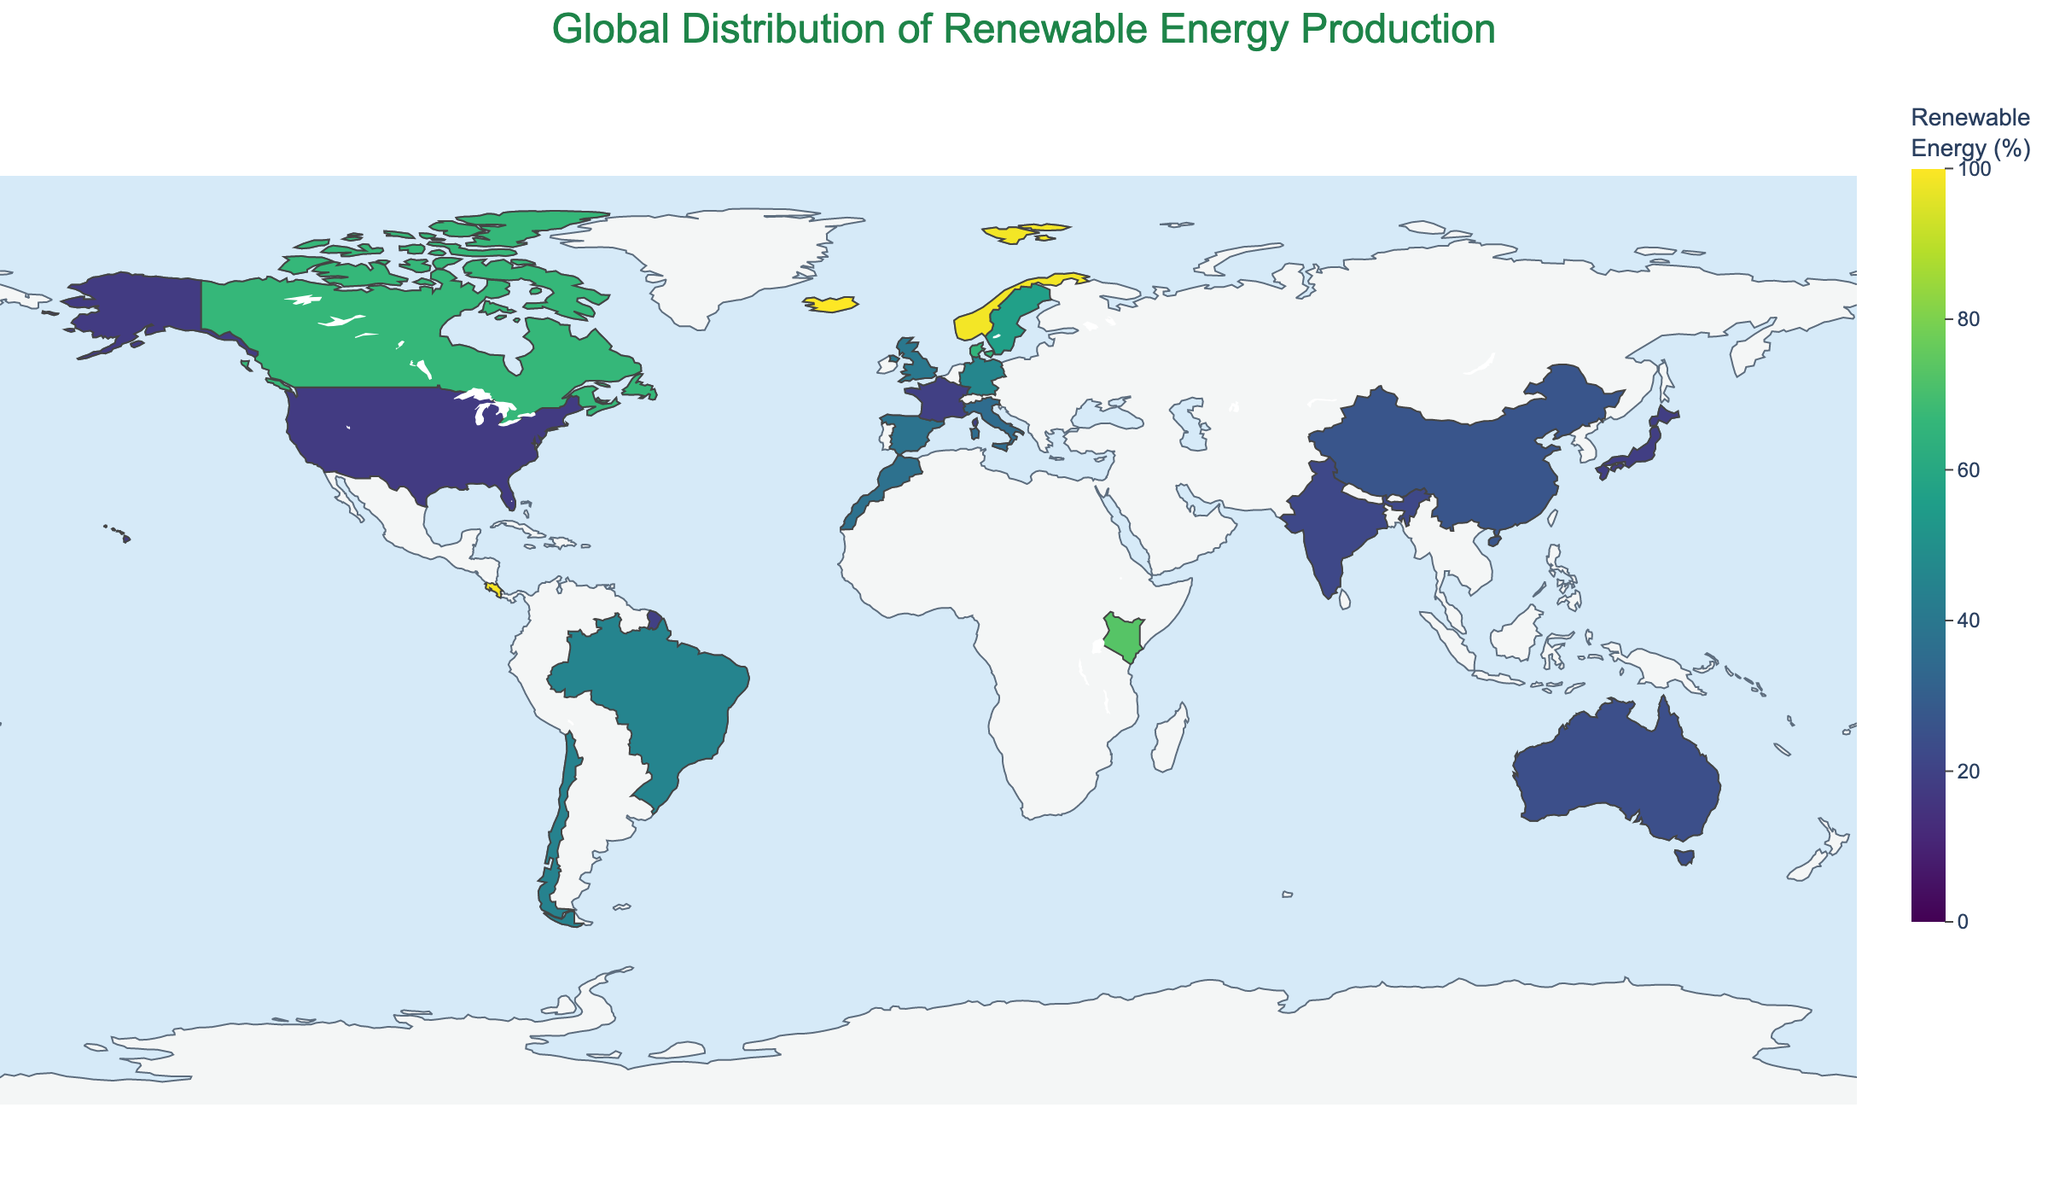Which country produced the highest percentage of renewable energy? Looking at the plot, the color scale represents renewable energy percentages ranging from 0 to 100%. Iceland is at the highest end of this scale, with a percentage of 100%.
Answer: Iceland What is the renewable energy percentage for Kenya? Referring to the values in the figure, Kenya shows a renewable energy percentage, which can be identified by its color and corresponding hover information. Kenya's renewable energy percentage is 73.1%.
Answer: 73.1% Which continent has the highest average renewable energy production percentage based on the countries shown? By visually inspecting the plot and considering countries from each continent, we calculate the average renewable energy percentages:
- Europe: Germany (46.1), Spain (37.9), UK (40.2), Italy (35.1), Sweden (56.4), Denmark (65.3), Norway (98.4) => Average: (46.1 + 37.9 + 40.2 + 35.1 + 56.4 + 65.3 + 98.4) / 7 ≈ 54.2
- North America: USA (17.5), Canada (66.5) => Average: (17.5 + 66.5) / 2 ≈ 42.0
- South America: Brazil (45.3), Chile (44.5), Costa Rica (99.2) => Average: (45.3 + 44.5 + 99.2) / 3 ≈ 63.0
- Asia: China (26.4), India (21.8), Japan (18.5) => Average: (26.4 + 21.8 + 18.5) / 3 ≈ 22.2
- Africa: Morocco (37.2), Kenya (73.1) => Average: (37.2 + 73.1) / 2 ≈ 55.15
Therefore, South America has the highest average renewable energy production percentage.
Answer: South America Between Germany and Denmark, which country has a greater renewable energy percentage? Comparing the two percentages, Germany has 46.1% whereas Denmark has 65.3%. Since 65.3% is greater than 46.1%, Denmark has a higher renewable energy percentage.
Answer: Denmark Is the renewable energy production percentage in Morocco higher than in Japan and India combined? Morocco's renewable energy percentage is 37.2%. Japan's is 18.5%, and India's is 21.8%. Summing Japan and India's percentages: 18.5 + 21.8 = 40.3. Comparing 37.2 with 40.3, Morocco's percentage is lower than the combined percentage of Japan and India.
Answer: No What's the range of the data shown on the plot? The range of the data can be identified by looking at the minimum and maximum values represented on the scale. The minimum value is for the USA with 17.5%, and the maximum is for Iceland with 100%. Therefore, the range is 100 - 17.5 = 82.5 percentage points.
Answer: 82.5 Which country has the second highest percentage of renewable energy production? Rechecking the figure, Costa Rica has the second-highest renewable energy percentage of 99.2%, just after Iceland at 100%.
Answer: Costa Rica What are the renewable energy percentages of the top 3 European countries? Referring again to the individual countries, Norway has 98.4%, Denmark has 65.3%, and Sweden has 56.4%. These are the top three European countries in terms of renewable energy production.
Answer: Norway: 98.4%, Denmark: 65.3%, Sweden: 56.4% If you sum the renewable energy percentages of the United States, China, and India, what is the total? The renewable energy percentages are United States: 17.5%, China: 26.4%, and India: 21.8%. Adding them together: 17.5 + 26.4 + 21.8 = 65.7.
Answer: 65.7 